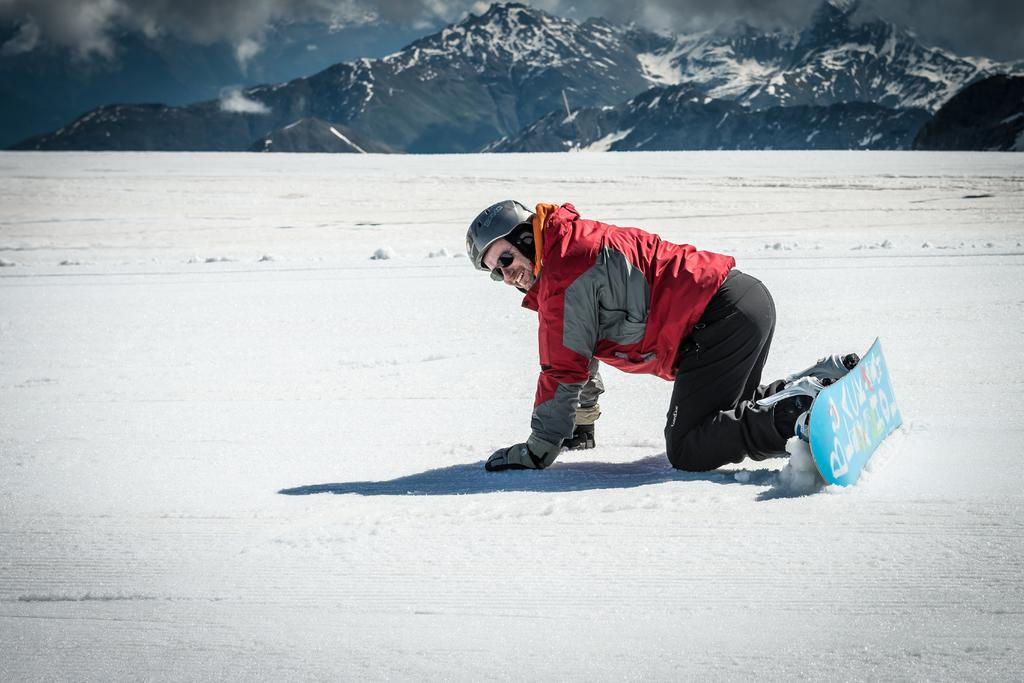What is the main subject of the image? There is a person in the image. What is the person wearing in the image? The person is wearing a skateboard in the image. What is the person doing in the image? The person is kneeling on the surface of the snow in the image. What can be seen in the background of the image? Mountains and the sky are visible in the background of the image. How many bees can be seen buzzing around the person in the image? There are no bees present in the image. 